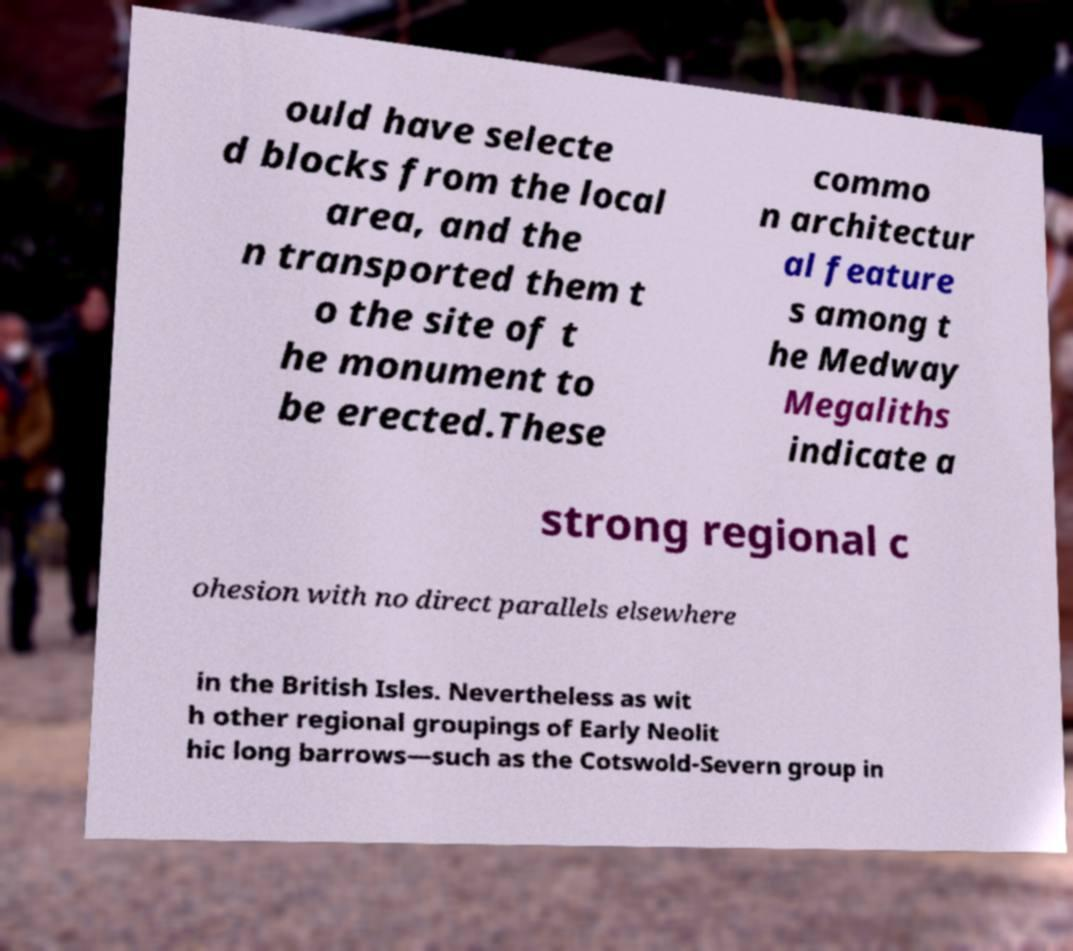Could you extract and type out the text from this image? ould have selecte d blocks from the local area, and the n transported them t o the site of t he monument to be erected.These commo n architectur al feature s among t he Medway Megaliths indicate a strong regional c ohesion with no direct parallels elsewhere in the British Isles. Nevertheless as wit h other regional groupings of Early Neolit hic long barrows—such as the Cotswold-Severn group in 